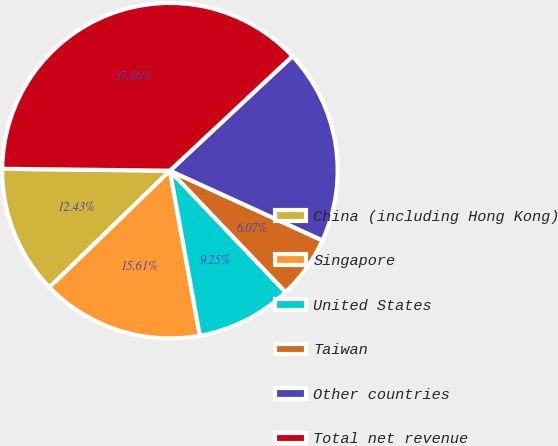<chart> <loc_0><loc_0><loc_500><loc_500><pie_chart><fcel>China (including Hong Kong)<fcel>Singapore<fcel>United States<fcel>Taiwan<fcel>Other countries<fcel>Total net revenue<nl><fcel>12.43%<fcel>15.61%<fcel>9.25%<fcel>6.07%<fcel>18.79%<fcel>37.86%<nl></chart> 